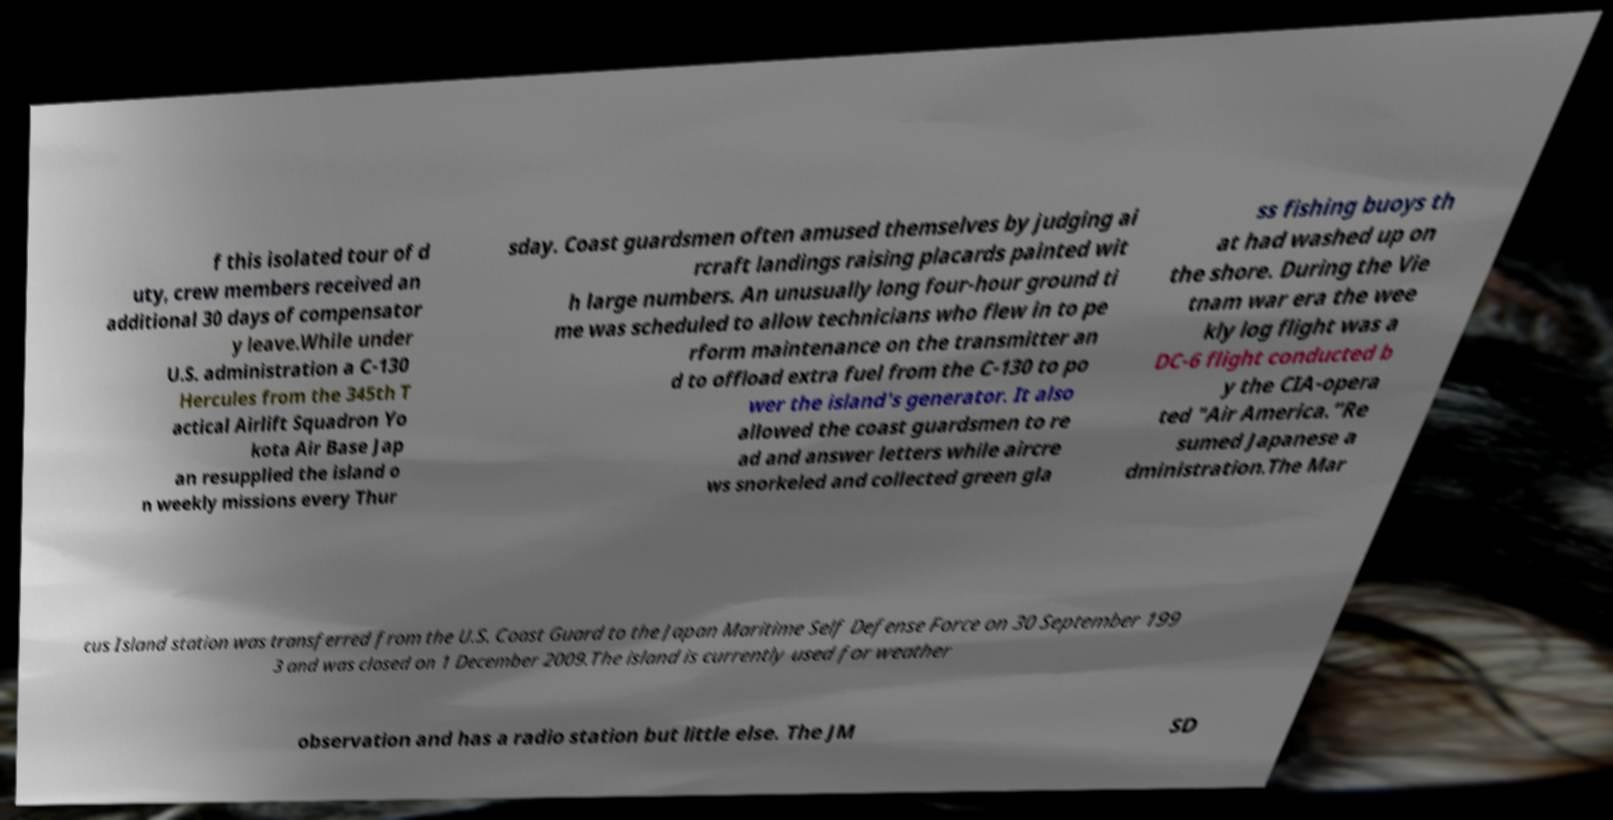What messages or text are displayed in this image? I need them in a readable, typed format. f this isolated tour of d uty, crew members received an additional 30 days of compensator y leave.While under U.S. administration a C-130 Hercules from the 345th T actical Airlift Squadron Yo kota Air Base Jap an resupplied the island o n weekly missions every Thur sday. Coast guardsmen often amused themselves by judging ai rcraft landings raising placards painted wit h large numbers. An unusually long four-hour ground ti me was scheduled to allow technicians who flew in to pe rform maintenance on the transmitter an d to offload extra fuel from the C-130 to po wer the island's generator. It also allowed the coast guardsmen to re ad and answer letters while aircre ws snorkeled and collected green gla ss fishing buoys th at had washed up on the shore. During the Vie tnam war era the wee kly log flight was a DC-6 flight conducted b y the CIA-opera ted "Air America.”Re sumed Japanese a dministration.The Mar cus Island station was transferred from the U.S. Coast Guard to the Japan Maritime Self Defense Force on 30 September 199 3 and was closed on 1 December 2009.The island is currently used for weather observation and has a radio station but little else. The JM SD 